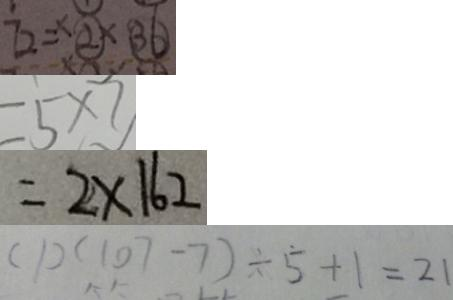Convert formula to latex. <formula><loc_0><loc_0><loc_500><loc_500>7 2 = \times \textcircled { 2 } \times \textcircled { 3 6 } 
 = 5 \times 7 
 = 2 \times 1 6 2 
 ( 1 ) ( 1 0 7 - 7 ) \div \dot { 5 } + 1 = 2 1</formula> 